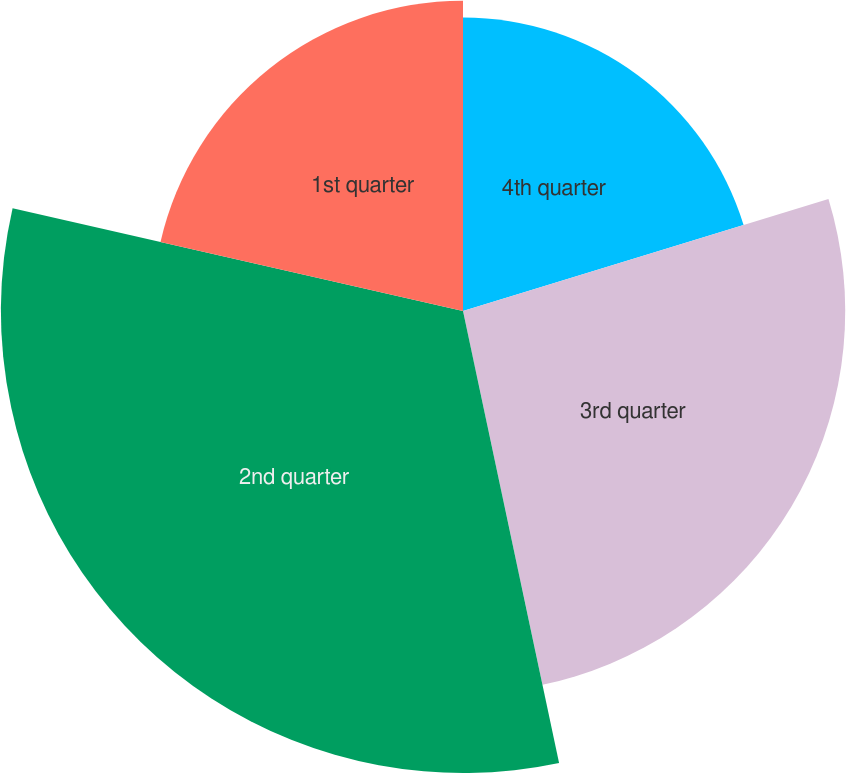Convert chart to OTSL. <chart><loc_0><loc_0><loc_500><loc_500><pie_chart><fcel>4th quarter<fcel>3rd quarter<fcel>2nd quarter<fcel>1st quarter<nl><fcel>20.27%<fcel>26.4%<fcel>31.91%<fcel>21.43%<nl></chart> 